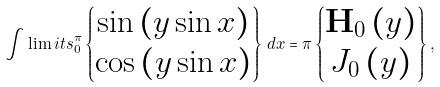Convert formula to latex. <formula><loc_0><loc_0><loc_500><loc_500>\int \lim i t s _ { 0 } ^ { \pi } \begin{Bmatrix} \sin \left ( y \sin x \right ) \\ \cos \left ( y \sin x \right ) \end{Bmatrix} \, d x = \pi \begin{Bmatrix} \mathbf H _ { 0 } \left ( y \right ) \\ J _ { 0 } \left ( y \right ) \end{Bmatrix} ,</formula> 